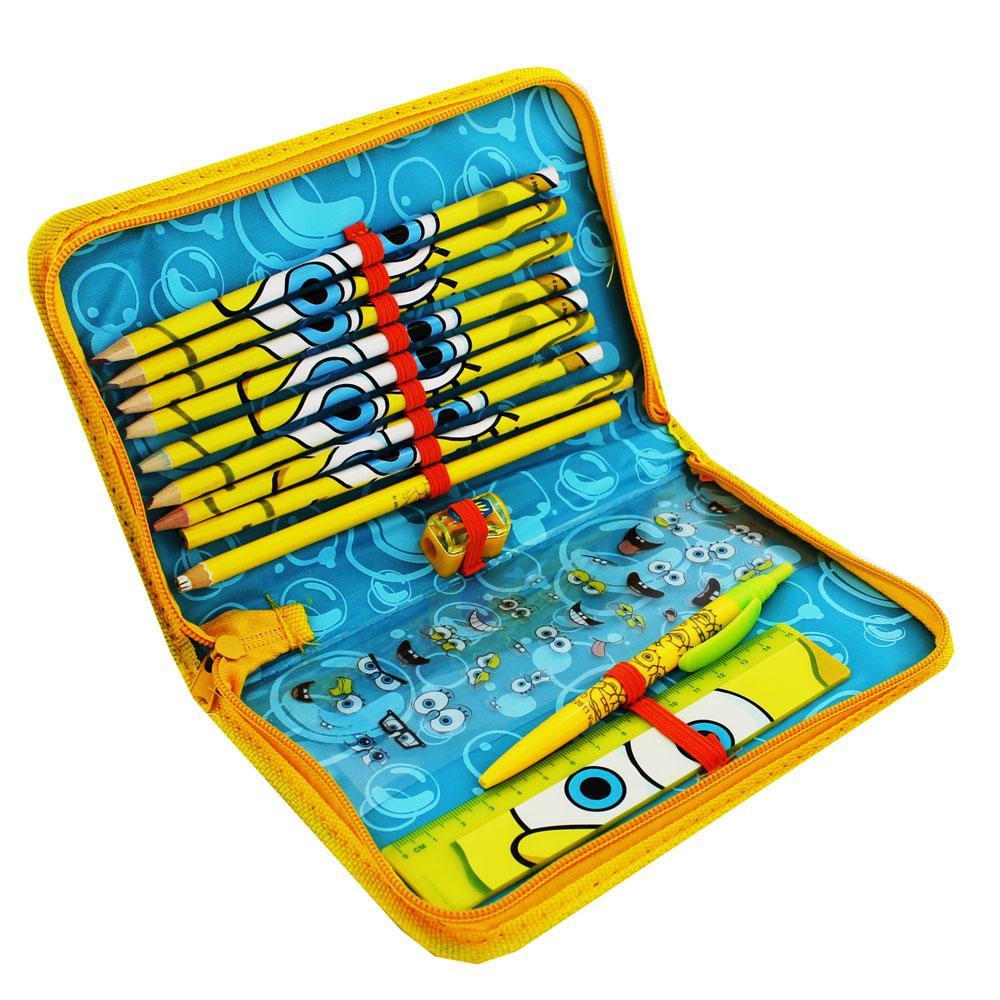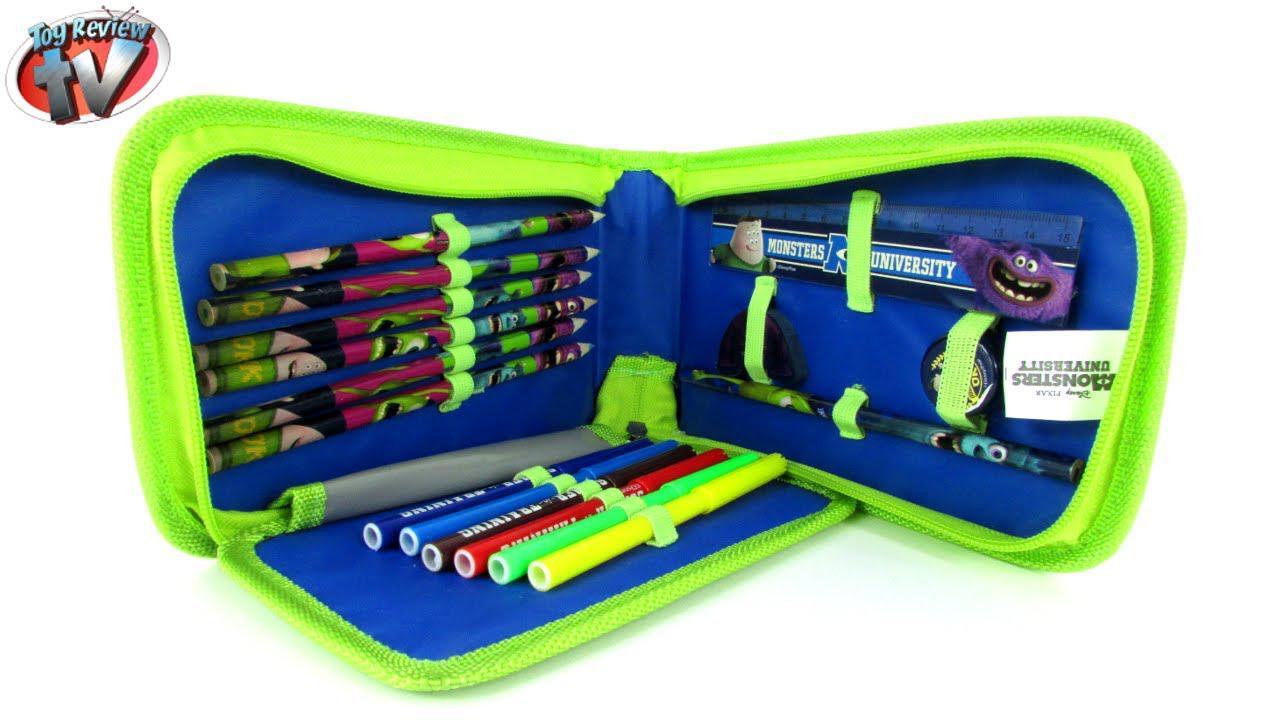The first image is the image on the left, the second image is the image on the right. Examine the images to the left and right. Is the description "Each image shows a single closed case, and all cases feature blue in their color scheme." accurate? Answer yes or no. No. The first image is the image on the left, the second image is the image on the right. Evaluate the accuracy of this statement regarding the images: "There are only two pencil cases, and both are closed.". Is it true? Answer yes or no. No. 